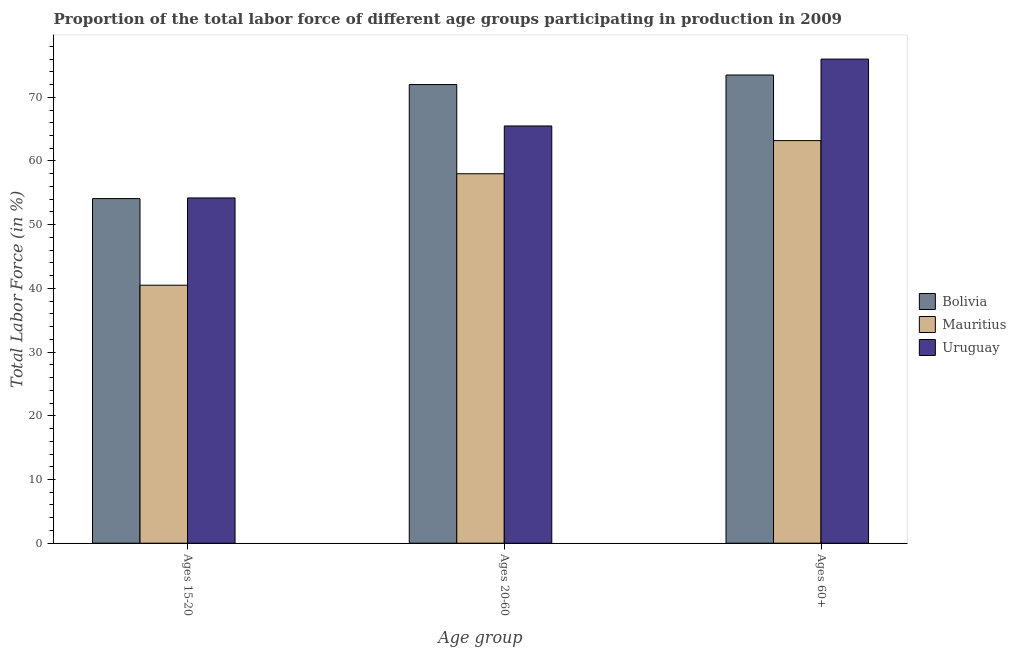How many different coloured bars are there?
Provide a short and direct response. 3. How many groups of bars are there?
Keep it short and to the point. 3. What is the label of the 1st group of bars from the left?
Give a very brief answer. Ages 15-20. What is the percentage of labor force within the age group 20-60 in Mauritius?
Your answer should be very brief. 58. Across all countries, what is the maximum percentage of labor force within the age group 15-20?
Provide a succinct answer. 54.2. Across all countries, what is the minimum percentage of labor force within the age group 20-60?
Provide a short and direct response. 58. In which country was the percentage of labor force above age 60 maximum?
Offer a terse response. Uruguay. In which country was the percentage of labor force within the age group 15-20 minimum?
Keep it short and to the point. Mauritius. What is the total percentage of labor force within the age group 15-20 in the graph?
Keep it short and to the point. 148.8. What is the difference between the percentage of labor force within the age group 15-20 in Mauritius and that in Uruguay?
Your answer should be compact. -13.7. What is the difference between the percentage of labor force above age 60 in Mauritius and the percentage of labor force within the age group 20-60 in Bolivia?
Provide a succinct answer. -8.8. What is the average percentage of labor force within the age group 15-20 per country?
Your answer should be compact. 49.6. What is the difference between the percentage of labor force above age 60 and percentage of labor force within the age group 15-20 in Mauritius?
Ensure brevity in your answer.  22.7. In how many countries, is the percentage of labor force above age 60 greater than 16 %?
Provide a succinct answer. 3. What is the ratio of the percentage of labor force within the age group 15-20 in Mauritius to that in Uruguay?
Your response must be concise. 0.75. Is the difference between the percentage of labor force within the age group 15-20 in Bolivia and Mauritius greater than the difference between the percentage of labor force above age 60 in Bolivia and Mauritius?
Your answer should be very brief. Yes. What is the difference between the highest and the second highest percentage of labor force within the age group 15-20?
Your answer should be compact. 0.1. What is the difference between the highest and the lowest percentage of labor force above age 60?
Ensure brevity in your answer.  12.8. What does the 1st bar from the right in Ages 15-20 represents?
Keep it short and to the point. Uruguay. Are all the bars in the graph horizontal?
Provide a succinct answer. No. Does the graph contain any zero values?
Provide a succinct answer. No. Does the graph contain grids?
Your answer should be very brief. No. How many legend labels are there?
Your answer should be compact. 3. What is the title of the graph?
Give a very brief answer. Proportion of the total labor force of different age groups participating in production in 2009. Does "Sudan" appear as one of the legend labels in the graph?
Your answer should be very brief. No. What is the label or title of the X-axis?
Provide a succinct answer. Age group. What is the label or title of the Y-axis?
Your answer should be compact. Total Labor Force (in %). What is the Total Labor Force (in %) of Bolivia in Ages 15-20?
Provide a succinct answer. 54.1. What is the Total Labor Force (in %) in Mauritius in Ages 15-20?
Your response must be concise. 40.5. What is the Total Labor Force (in %) of Uruguay in Ages 15-20?
Your answer should be compact. 54.2. What is the Total Labor Force (in %) of Bolivia in Ages 20-60?
Provide a succinct answer. 72. What is the Total Labor Force (in %) of Mauritius in Ages 20-60?
Your answer should be compact. 58. What is the Total Labor Force (in %) in Uruguay in Ages 20-60?
Provide a succinct answer. 65.5. What is the Total Labor Force (in %) in Bolivia in Ages 60+?
Offer a terse response. 73.5. What is the Total Labor Force (in %) in Mauritius in Ages 60+?
Your answer should be compact. 63.2. What is the Total Labor Force (in %) of Uruguay in Ages 60+?
Provide a succinct answer. 76. Across all Age group, what is the maximum Total Labor Force (in %) of Bolivia?
Give a very brief answer. 73.5. Across all Age group, what is the maximum Total Labor Force (in %) of Mauritius?
Give a very brief answer. 63.2. Across all Age group, what is the minimum Total Labor Force (in %) of Bolivia?
Your response must be concise. 54.1. Across all Age group, what is the minimum Total Labor Force (in %) of Mauritius?
Keep it short and to the point. 40.5. Across all Age group, what is the minimum Total Labor Force (in %) in Uruguay?
Provide a succinct answer. 54.2. What is the total Total Labor Force (in %) in Bolivia in the graph?
Offer a terse response. 199.6. What is the total Total Labor Force (in %) in Mauritius in the graph?
Make the answer very short. 161.7. What is the total Total Labor Force (in %) of Uruguay in the graph?
Offer a very short reply. 195.7. What is the difference between the Total Labor Force (in %) of Bolivia in Ages 15-20 and that in Ages 20-60?
Your answer should be compact. -17.9. What is the difference between the Total Labor Force (in %) of Mauritius in Ages 15-20 and that in Ages 20-60?
Give a very brief answer. -17.5. What is the difference between the Total Labor Force (in %) of Uruguay in Ages 15-20 and that in Ages 20-60?
Keep it short and to the point. -11.3. What is the difference between the Total Labor Force (in %) in Bolivia in Ages 15-20 and that in Ages 60+?
Provide a short and direct response. -19.4. What is the difference between the Total Labor Force (in %) in Mauritius in Ages 15-20 and that in Ages 60+?
Make the answer very short. -22.7. What is the difference between the Total Labor Force (in %) in Uruguay in Ages 15-20 and that in Ages 60+?
Make the answer very short. -21.8. What is the difference between the Total Labor Force (in %) in Mauritius in Ages 20-60 and that in Ages 60+?
Keep it short and to the point. -5.2. What is the difference between the Total Labor Force (in %) in Uruguay in Ages 20-60 and that in Ages 60+?
Keep it short and to the point. -10.5. What is the difference between the Total Labor Force (in %) in Mauritius in Ages 15-20 and the Total Labor Force (in %) in Uruguay in Ages 20-60?
Offer a very short reply. -25. What is the difference between the Total Labor Force (in %) in Bolivia in Ages 15-20 and the Total Labor Force (in %) in Mauritius in Ages 60+?
Your answer should be compact. -9.1. What is the difference between the Total Labor Force (in %) in Bolivia in Ages 15-20 and the Total Labor Force (in %) in Uruguay in Ages 60+?
Provide a short and direct response. -21.9. What is the difference between the Total Labor Force (in %) in Mauritius in Ages 15-20 and the Total Labor Force (in %) in Uruguay in Ages 60+?
Offer a terse response. -35.5. What is the difference between the Total Labor Force (in %) in Bolivia in Ages 20-60 and the Total Labor Force (in %) in Mauritius in Ages 60+?
Offer a very short reply. 8.8. What is the difference between the Total Labor Force (in %) in Bolivia in Ages 20-60 and the Total Labor Force (in %) in Uruguay in Ages 60+?
Make the answer very short. -4. What is the difference between the Total Labor Force (in %) of Mauritius in Ages 20-60 and the Total Labor Force (in %) of Uruguay in Ages 60+?
Offer a very short reply. -18. What is the average Total Labor Force (in %) in Bolivia per Age group?
Make the answer very short. 66.53. What is the average Total Labor Force (in %) in Mauritius per Age group?
Your answer should be very brief. 53.9. What is the average Total Labor Force (in %) of Uruguay per Age group?
Your answer should be compact. 65.23. What is the difference between the Total Labor Force (in %) in Bolivia and Total Labor Force (in %) in Mauritius in Ages 15-20?
Provide a succinct answer. 13.6. What is the difference between the Total Labor Force (in %) in Mauritius and Total Labor Force (in %) in Uruguay in Ages 15-20?
Give a very brief answer. -13.7. What is the difference between the Total Labor Force (in %) of Mauritius and Total Labor Force (in %) of Uruguay in Ages 20-60?
Your response must be concise. -7.5. What is the difference between the Total Labor Force (in %) in Bolivia and Total Labor Force (in %) in Uruguay in Ages 60+?
Provide a succinct answer. -2.5. What is the ratio of the Total Labor Force (in %) in Bolivia in Ages 15-20 to that in Ages 20-60?
Provide a succinct answer. 0.75. What is the ratio of the Total Labor Force (in %) of Mauritius in Ages 15-20 to that in Ages 20-60?
Ensure brevity in your answer.  0.7. What is the ratio of the Total Labor Force (in %) of Uruguay in Ages 15-20 to that in Ages 20-60?
Provide a short and direct response. 0.83. What is the ratio of the Total Labor Force (in %) of Bolivia in Ages 15-20 to that in Ages 60+?
Make the answer very short. 0.74. What is the ratio of the Total Labor Force (in %) of Mauritius in Ages 15-20 to that in Ages 60+?
Make the answer very short. 0.64. What is the ratio of the Total Labor Force (in %) in Uruguay in Ages 15-20 to that in Ages 60+?
Your answer should be very brief. 0.71. What is the ratio of the Total Labor Force (in %) of Bolivia in Ages 20-60 to that in Ages 60+?
Offer a terse response. 0.98. What is the ratio of the Total Labor Force (in %) of Mauritius in Ages 20-60 to that in Ages 60+?
Make the answer very short. 0.92. What is the ratio of the Total Labor Force (in %) of Uruguay in Ages 20-60 to that in Ages 60+?
Your answer should be very brief. 0.86. What is the difference between the highest and the second highest Total Labor Force (in %) of Bolivia?
Make the answer very short. 1.5. What is the difference between the highest and the lowest Total Labor Force (in %) of Mauritius?
Offer a terse response. 22.7. What is the difference between the highest and the lowest Total Labor Force (in %) in Uruguay?
Keep it short and to the point. 21.8. 